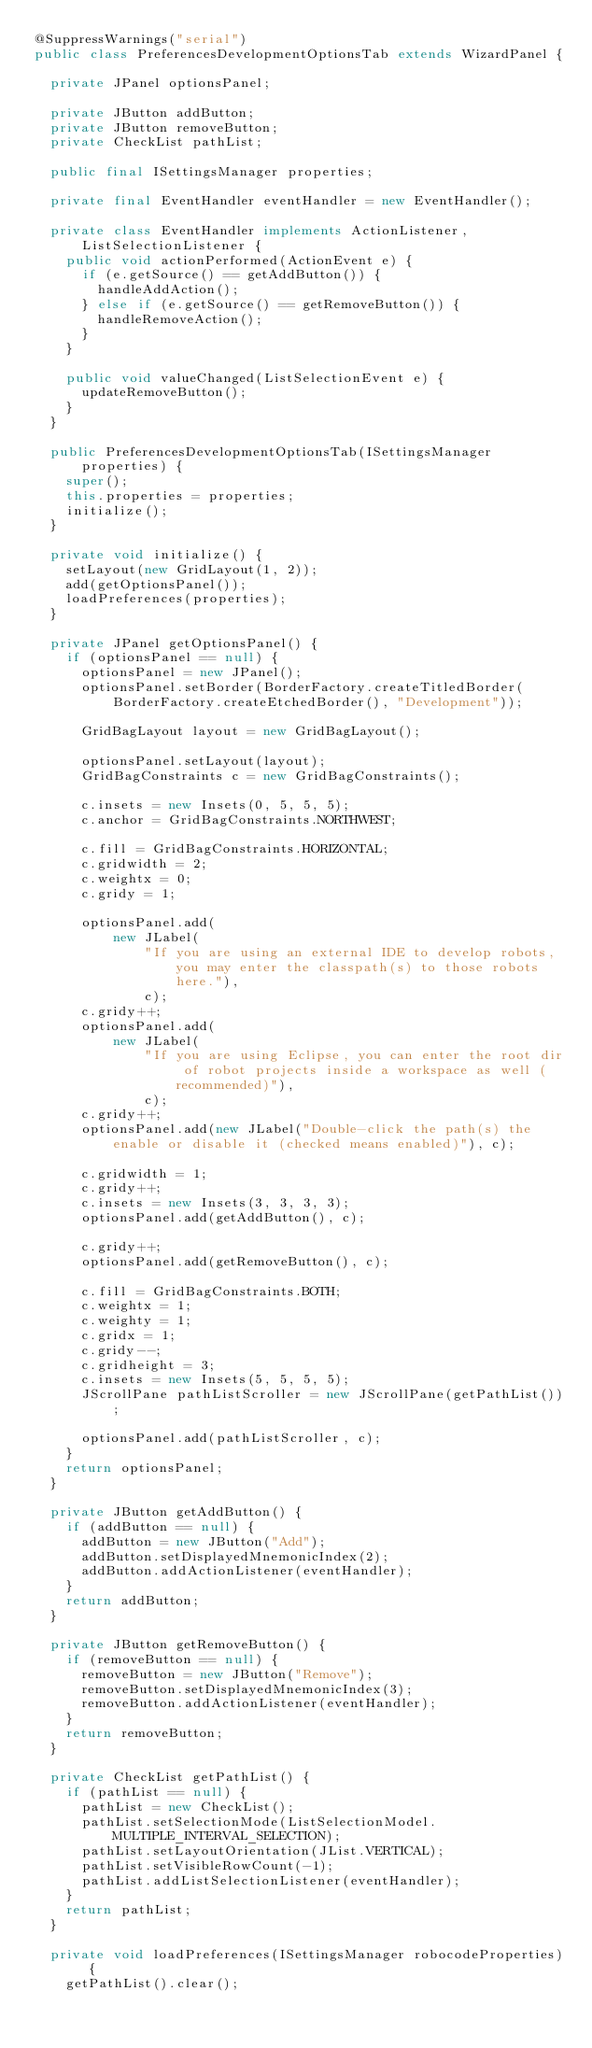Convert code to text. <code><loc_0><loc_0><loc_500><loc_500><_Java_>@SuppressWarnings("serial")
public class PreferencesDevelopmentOptionsTab extends WizardPanel {

	private JPanel optionsPanel;

	private JButton addButton;
	private JButton removeButton;
	private CheckList pathList;

	public final ISettingsManager properties;

	private final EventHandler eventHandler = new EventHandler();

	private class EventHandler implements ActionListener, ListSelectionListener {
		public void actionPerformed(ActionEvent e) {
			if (e.getSource() == getAddButton()) {
				handleAddAction();
			} else if (e.getSource() == getRemoveButton()) {
				handleRemoveAction();
			}
		}

		public void valueChanged(ListSelectionEvent e) {			
			updateRemoveButton();
		}
	}

	public PreferencesDevelopmentOptionsTab(ISettingsManager properties) {
		super();
		this.properties = properties;
		initialize();
	}

	private void initialize() {
		setLayout(new GridLayout(1, 2));
		add(getOptionsPanel());
		loadPreferences(properties);
	}

	private JPanel getOptionsPanel() {
		if (optionsPanel == null) {
			optionsPanel = new JPanel();
			optionsPanel.setBorder(BorderFactory.createTitledBorder(BorderFactory.createEtchedBorder(), "Development"));

			GridBagLayout layout = new GridBagLayout();

			optionsPanel.setLayout(layout);
			GridBagConstraints c = new GridBagConstraints();

			c.insets = new Insets(0, 5, 5, 5);
			c.anchor = GridBagConstraints.NORTHWEST;

			c.fill = GridBagConstraints.HORIZONTAL;
			c.gridwidth = 2;
			c.weightx = 0;
			c.gridy = 1;

			optionsPanel.add(
					new JLabel(
							"If you are using an external IDE to develop robots, you may enter the classpath(s) to those robots here."),
							c);
			c.gridy++;
			optionsPanel.add(
					new JLabel(
							"If you are using Eclipse, you can enter the root dir of robot projects inside a workspace as well (recommended)"),
							c);
			c.gridy++;
			optionsPanel.add(new JLabel("Double-click the path(s) the enable or disable it (checked means enabled)"), c);

			c.gridwidth = 1;
			c.gridy++;
			c.insets = new Insets(3, 3, 3, 3);
			optionsPanel.add(getAddButton(), c);

			c.gridy++;
			optionsPanel.add(getRemoveButton(), c);

			c.fill = GridBagConstraints.BOTH;
			c.weightx = 1;
			c.weighty = 1;
			c.gridx = 1;
			c.gridy--;
			c.gridheight = 3;
			c.insets = new Insets(5, 5, 5, 5);
			JScrollPane pathListScroller = new JScrollPane(getPathList());

			optionsPanel.add(pathListScroller, c);
		}
		return optionsPanel;
	}

	private JButton getAddButton() {
		if (addButton == null) {
			addButton = new JButton("Add");
			addButton.setDisplayedMnemonicIndex(2);
			addButton.addActionListener(eventHandler);
		}
		return addButton;
	}

	private JButton getRemoveButton() {
		if (removeButton == null) {
			removeButton = new JButton("Remove");
			removeButton.setDisplayedMnemonicIndex(3);
			removeButton.addActionListener(eventHandler);
		}
		return removeButton;
	}

	private CheckList getPathList() {
		if (pathList == null) {
			pathList = new CheckList();
			pathList.setSelectionMode(ListSelectionModel.MULTIPLE_INTERVAL_SELECTION);
			pathList.setLayoutOrientation(JList.VERTICAL);
			pathList.setVisibleRowCount(-1);
			pathList.addListSelectionListener(eventHandler);
		}
		return pathList;
	}

	private void loadPreferences(ISettingsManager robocodeProperties) {
		getPathList().clear();
</code> 